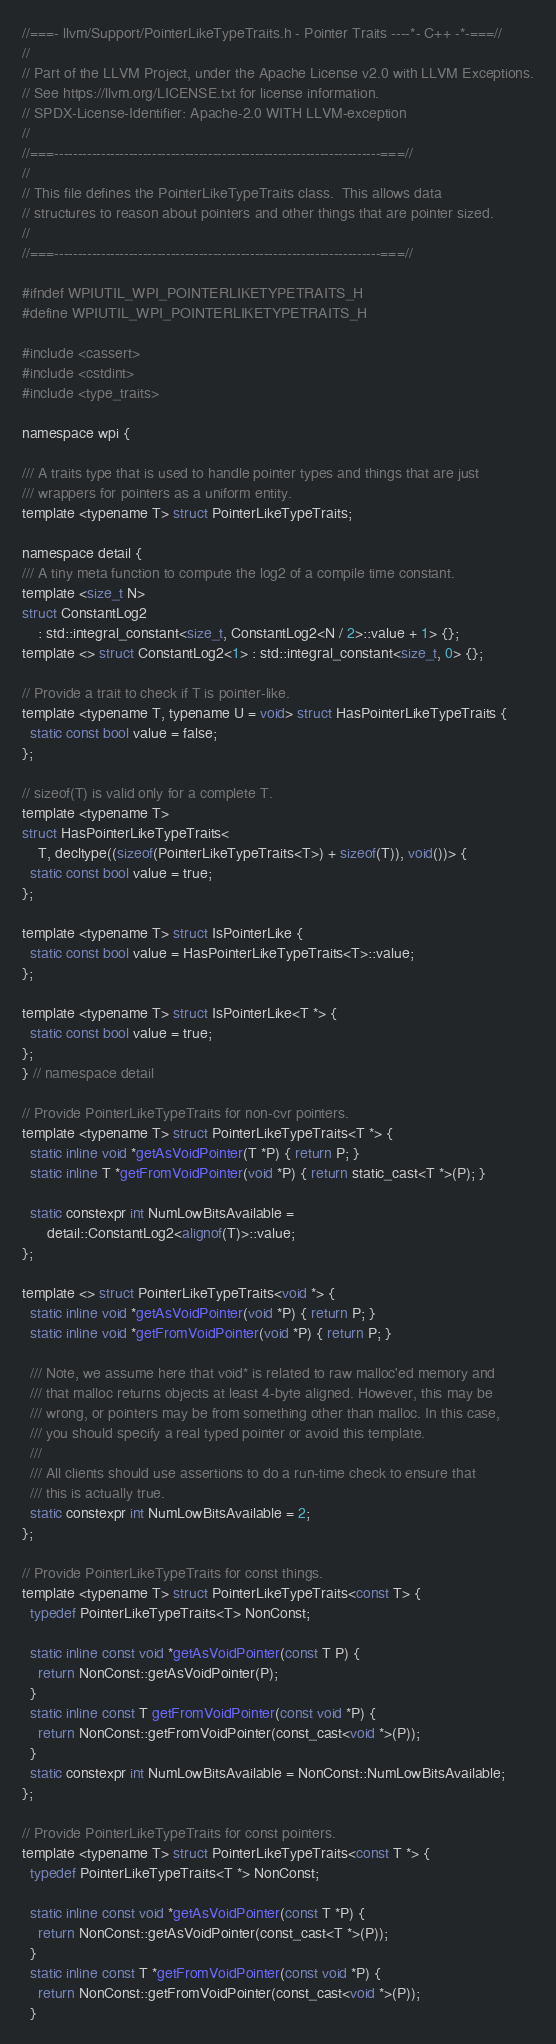Convert code to text. <code><loc_0><loc_0><loc_500><loc_500><_C_>//===- llvm/Support/PointerLikeTypeTraits.h - Pointer Traits ----*- C++ -*-===//
//
// Part of the LLVM Project, under the Apache License v2.0 with LLVM Exceptions.
// See https://llvm.org/LICENSE.txt for license information.
// SPDX-License-Identifier: Apache-2.0 WITH LLVM-exception
//
//===----------------------------------------------------------------------===//
//
// This file defines the PointerLikeTypeTraits class.  This allows data
// structures to reason about pointers and other things that are pointer sized.
//
//===----------------------------------------------------------------------===//

#ifndef WPIUTIL_WPI_POINTERLIKETYPETRAITS_H
#define WPIUTIL_WPI_POINTERLIKETYPETRAITS_H

#include <cassert>
#include <cstdint>
#include <type_traits>

namespace wpi {

/// A traits type that is used to handle pointer types and things that are just
/// wrappers for pointers as a uniform entity.
template <typename T> struct PointerLikeTypeTraits;

namespace detail {
/// A tiny meta function to compute the log2 of a compile time constant.
template <size_t N>
struct ConstantLog2
    : std::integral_constant<size_t, ConstantLog2<N / 2>::value + 1> {};
template <> struct ConstantLog2<1> : std::integral_constant<size_t, 0> {};

// Provide a trait to check if T is pointer-like.
template <typename T, typename U = void> struct HasPointerLikeTypeTraits {
  static const bool value = false;
};

// sizeof(T) is valid only for a complete T.
template <typename T>
struct HasPointerLikeTypeTraits<
    T, decltype((sizeof(PointerLikeTypeTraits<T>) + sizeof(T)), void())> {
  static const bool value = true;
};

template <typename T> struct IsPointerLike {
  static const bool value = HasPointerLikeTypeTraits<T>::value;
};

template <typename T> struct IsPointerLike<T *> {
  static const bool value = true;
};
} // namespace detail

// Provide PointerLikeTypeTraits for non-cvr pointers.
template <typename T> struct PointerLikeTypeTraits<T *> {
  static inline void *getAsVoidPointer(T *P) { return P; }
  static inline T *getFromVoidPointer(void *P) { return static_cast<T *>(P); }

  static constexpr int NumLowBitsAvailable =
      detail::ConstantLog2<alignof(T)>::value;
};

template <> struct PointerLikeTypeTraits<void *> {
  static inline void *getAsVoidPointer(void *P) { return P; }
  static inline void *getFromVoidPointer(void *P) { return P; }

  /// Note, we assume here that void* is related to raw malloc'ed memory and
  /// that malloc returns objects at least 4-byte aligned. However, this may be
  /// wrong, or pointers may be from something other than malloc. In this case,
  /// you should specify a real typed pointer or avoid this template.
  ///
  /// All clients should use assertions to do a run-time check to ensure that
  /// this is actually true.
  static constexpr int NumLowBitsAvailable = 2;
};

// Provide PointerLikeTypeTraits for const things.
template <typename T> struct PointerLikeTypeTraits<const T> {
  typedef PointerLikeTypeTraits<T> NonConst;

  static inline const void *getAsVoidPointer(const T P) {
    return NonConst::getAsVoidPointer(P);
  }
  static inline const T getFromVoidPointer(const void *P) {
    return NonConst::getFromVoidPointer(const_cast<void *>(P));
  }
  static constexpr int NumLowBitsAvailable = NonConst::NumLowBitsAvailable;
};

// Provide PointerLikeTypeTraits for const pointers.
template <typename T> struct PointerLikeTypeTraits<const T *> {
  typedef PointerLikeTypeTraits<T *> NonConst;

  static inline const void *getAsVoidPointer(const T *P) {
    return NonConst::getAsVoidPointer(const_cast<T *>(P));
  }
  static inline const T *getFromVoidPointer(const void *P) {
    return NonConst::getFromVoidPointer(const_cast<void *>(P));
  }</code> 